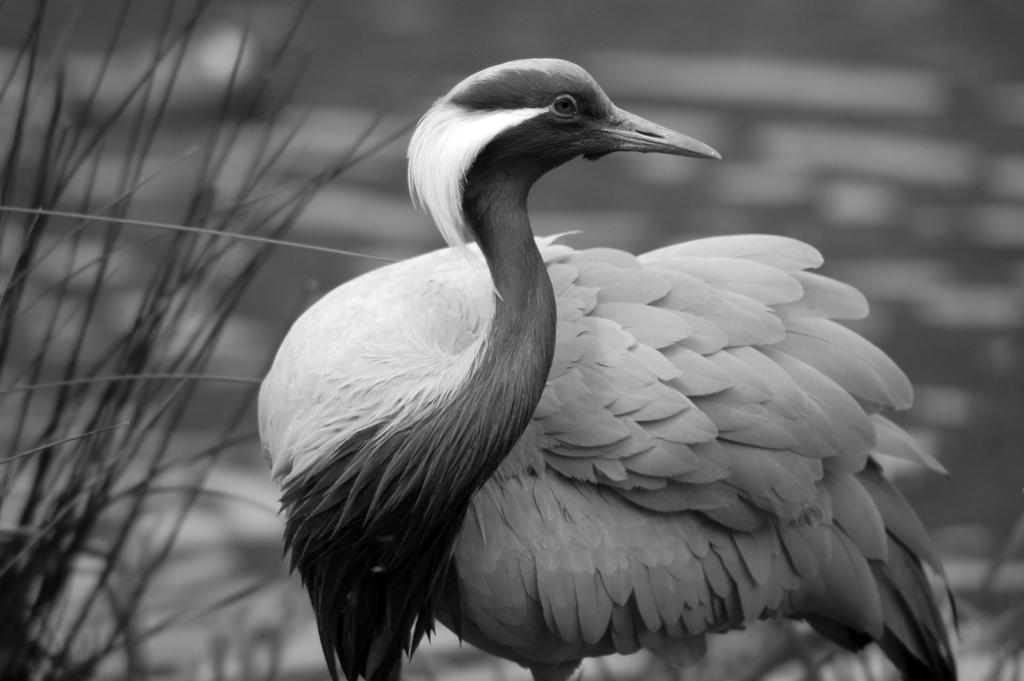What type of animal can be seen in the image? There is a bird in the image. What color is the bird? The bird is white in color. What type of vegetation is present in the image? There is grass in the image. How would you describe the background of the image? The background of the image is blurred. What color scheme is used in the image? The image is black and white. Can you see the bird's ear in the image? Birds do not have ears like humans, and there is no visible ear structure in the image. 